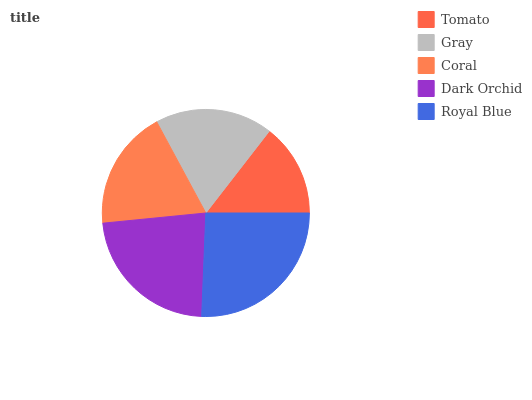Is Tomato the minimum?
Answer yes or no. Yes. Is Royal Blue the maximum?
Answer yes or no. Yes. Is Gray the minimum?
Answer yes or no. No. Is Gray the maximum?
Answer yes or no. No. Is Gray greater than Tomato?
Answer yes or no. Yes. Is Tomato less than Gray?
Answer yes or no. Yes. Is Tomato greater than Gray?
Answer yes or no. No. Is Gray less than Tomato?
Answer yes or no. No. Is Coral the high median?
Answer yes or no. Yes. Is Coral the low median?
Answer yes or no. Yes. Is Dark Orchid the high median?
Answer yes or no. No. Is Gray the low median?
Answer yes or no. No. 